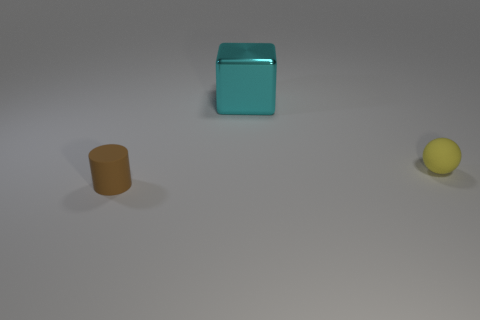Add 1 cyan blocks. How many objects exist? 4 Subtract all cubes. How many objects are left? 2 Add 1 tiny purple matte balls. How many tiny purple matte balls exist? 1 Subtract 1 brown cylinders. How many objects are left? 2 Subtract all yellow rubber things. Subtract all large cubes. How many objects are left? 1 Add 1 brown rubber objects. How many brown rubber objects are left? 2 